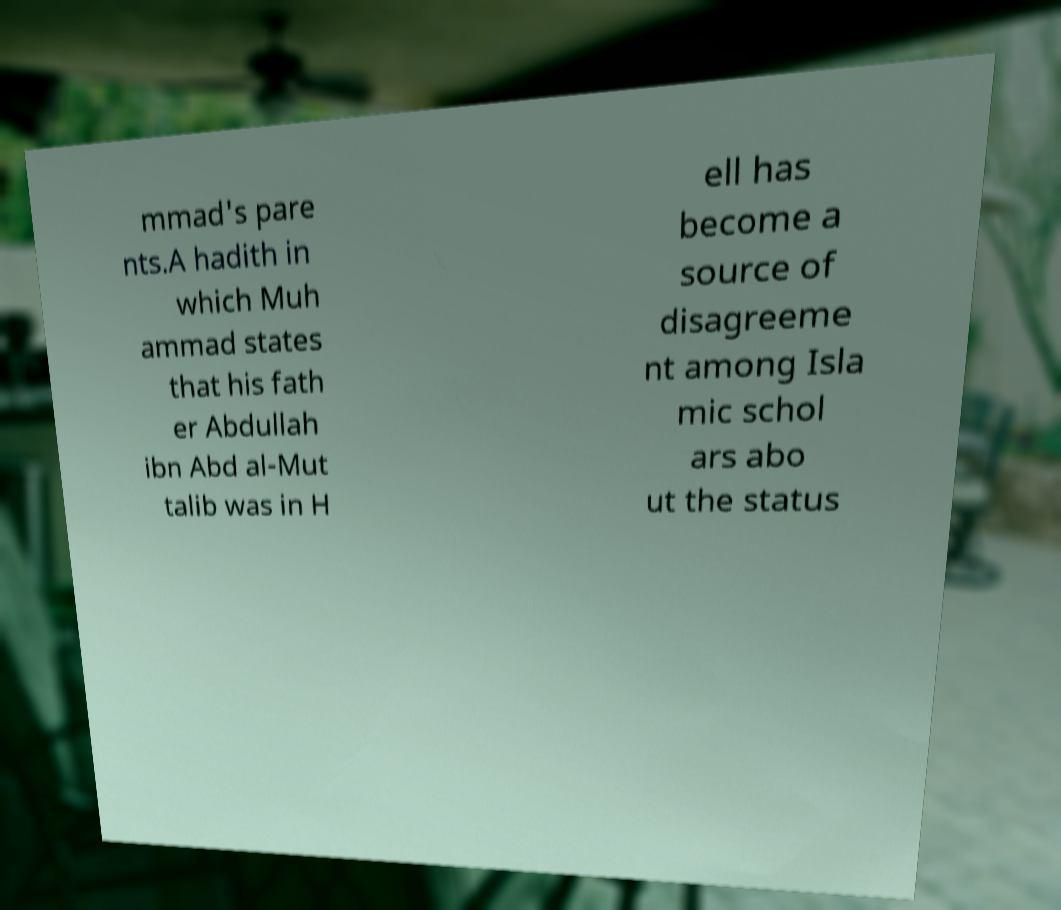For documentation purposes, I need the text within this image transcribed. Could you provide that? mmad's pare nts.A hadith in which Muh ammad states that his fath er Abdullah ibn Abd al-Mut talib was in H ell has become a source of disagreeme nt among Isla mic schol ars abo ut the status 